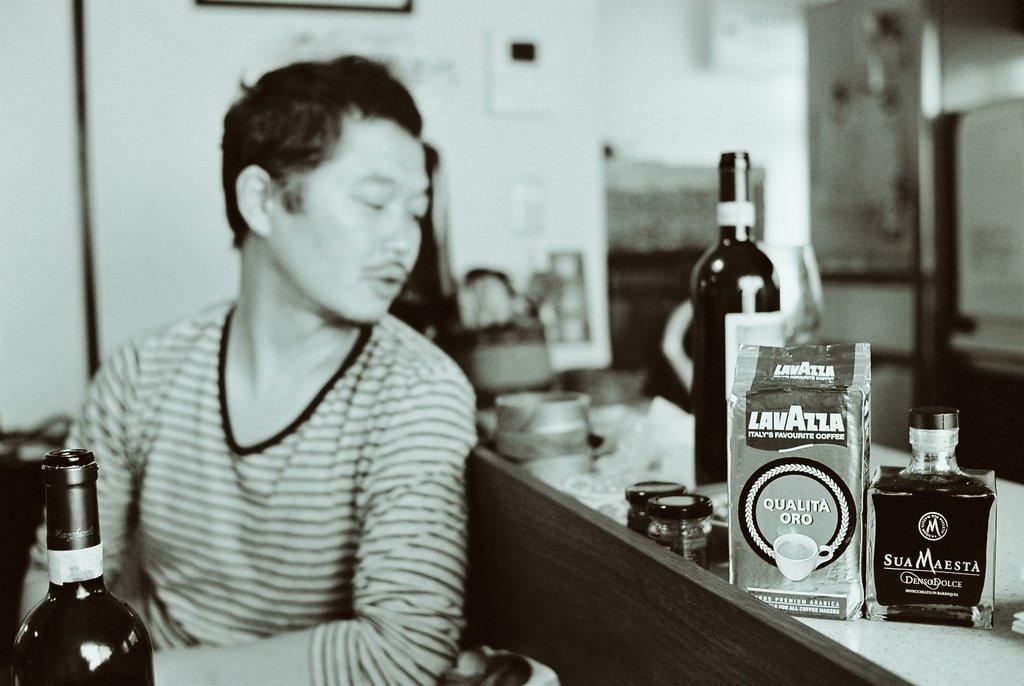What is the color scheme of the picture? The picture is black and white. Can you describe the main subject in the picture? There is a man in the picture. What other objects can be seen in the picture? There are bottles in the picture. Where is the bird's nest located in the picture? There is no bird's nest present in the picture. What type of machine can be seen in the image? There is no machine present in the image. 